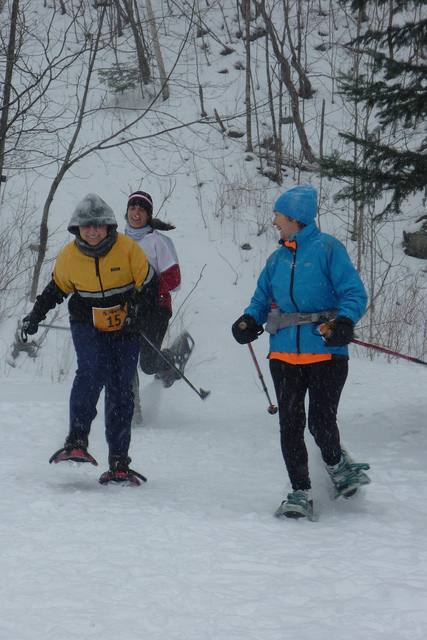Extract all visible text content from this image. 15 